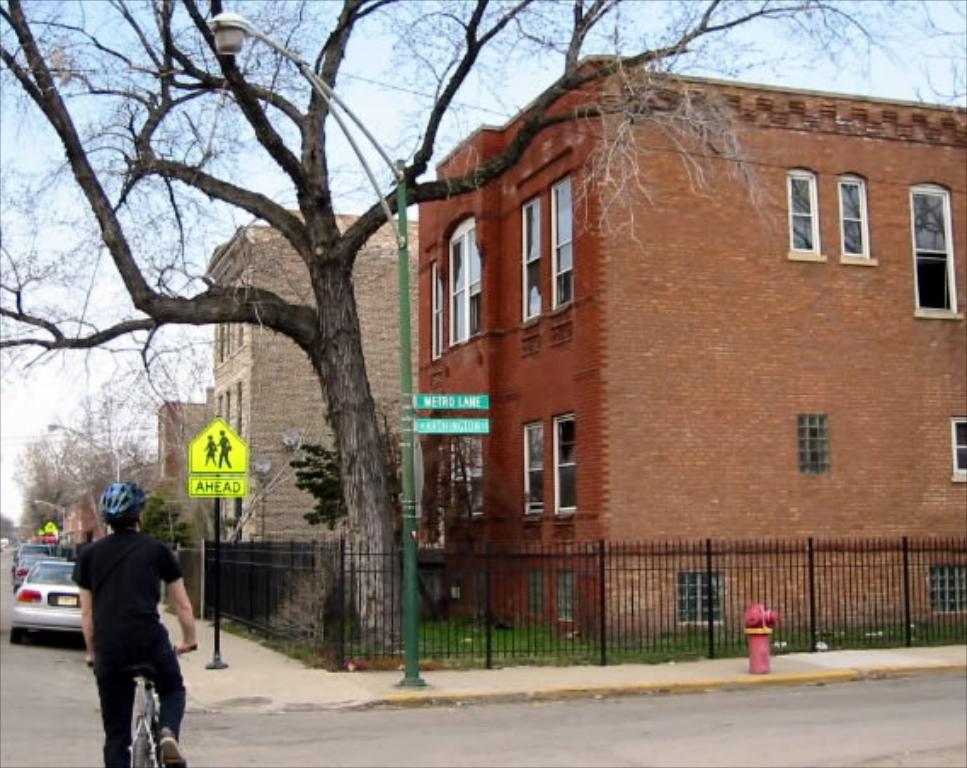In one or two sentences, can you explain what this image depicts? This image is taken outdoors. At the top of the image there is the sky. At the bottom of the image there is a road. On the left side of the image many cars are parked on the road. A man is riding on the bicycle. In the middle of the image there are few buildings. There are many trees with stems and branches. There are a few boards with text on them. There is a fence. There is a hydrant on the sidewalk. 